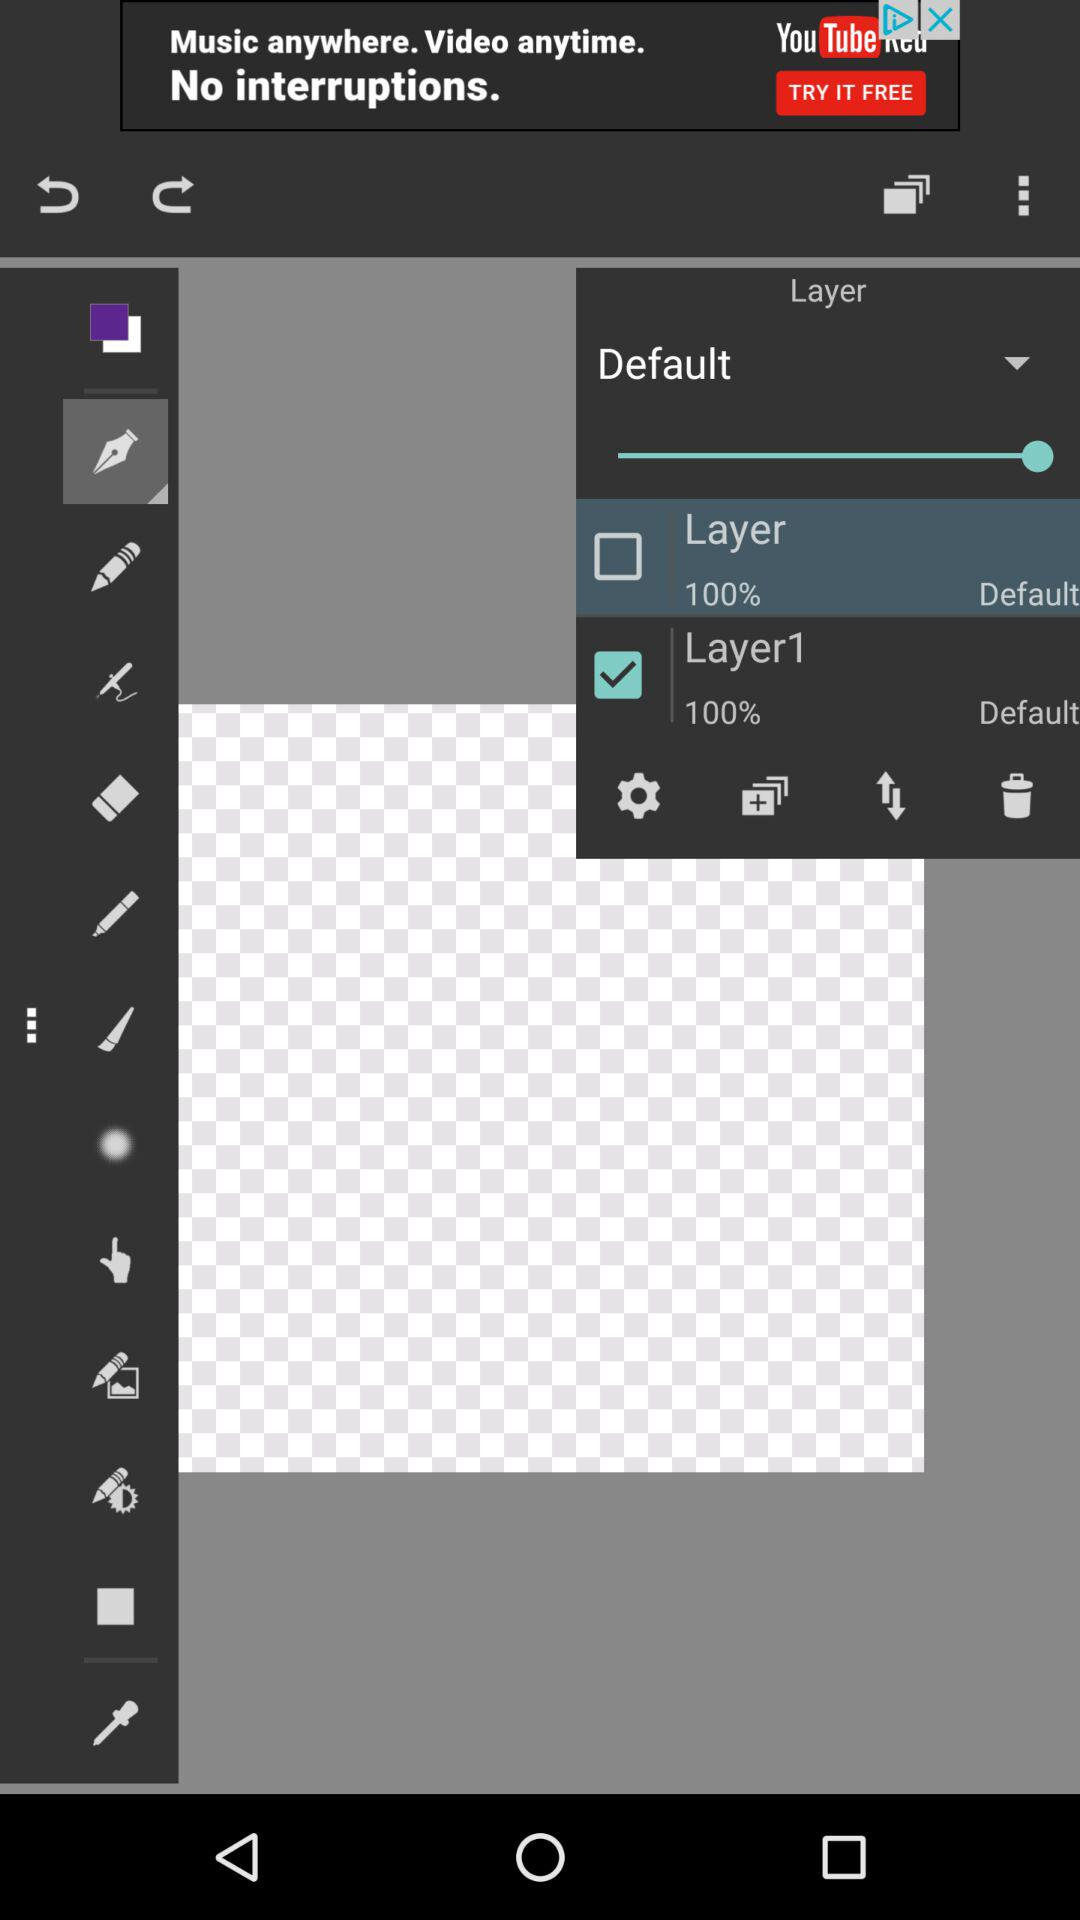Which layer is selected? The selected layer is "Layer1". 